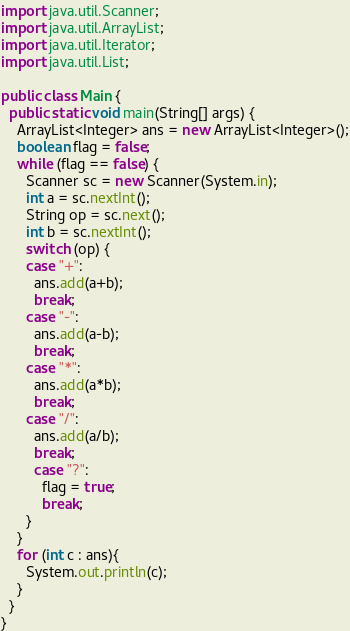<code> <loc_0><loc_0><loc_500><loc_500><_Java_>import java.util.Scanner;
import java.util.ArrayList;
import java.util.Iterator;
import java.util.List;

public class Main {
  public static void main(String[] args) {
    ArrayList<Integer> ans = new ArrayList<Integer>();
    boolean flag = false;
    while (flag == false) {
      Scanner sc = new Scanner(System.in);
      int a = sc.nextInt();
      String op = sc.next();
      int b = sc.nextInt();
      switch (op) {
      case "+":
        ans.add(a+b);
        break;
      case "-":
        ans.add(a-b);
        break;
      case "*":
        ans.add(a*b);
        break;
      case "/":
        ans.add(a/b);
        break;
        case "?":
          flag = true;
          break;
      }
    }
    for (int c : ans){
      System.out.println(c);
    }
  }
}

</code> 